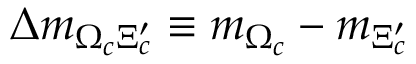<formula> <loc_0><loc_0><loc_500><loc_500>\Delta m _ { \Omega _ { c } \Xi _ { c } ^ { \prime } } \equiv m _ { \Omega _ { c } } - m _ { \Xi _ { c } ^ { \prime } }</formula> 